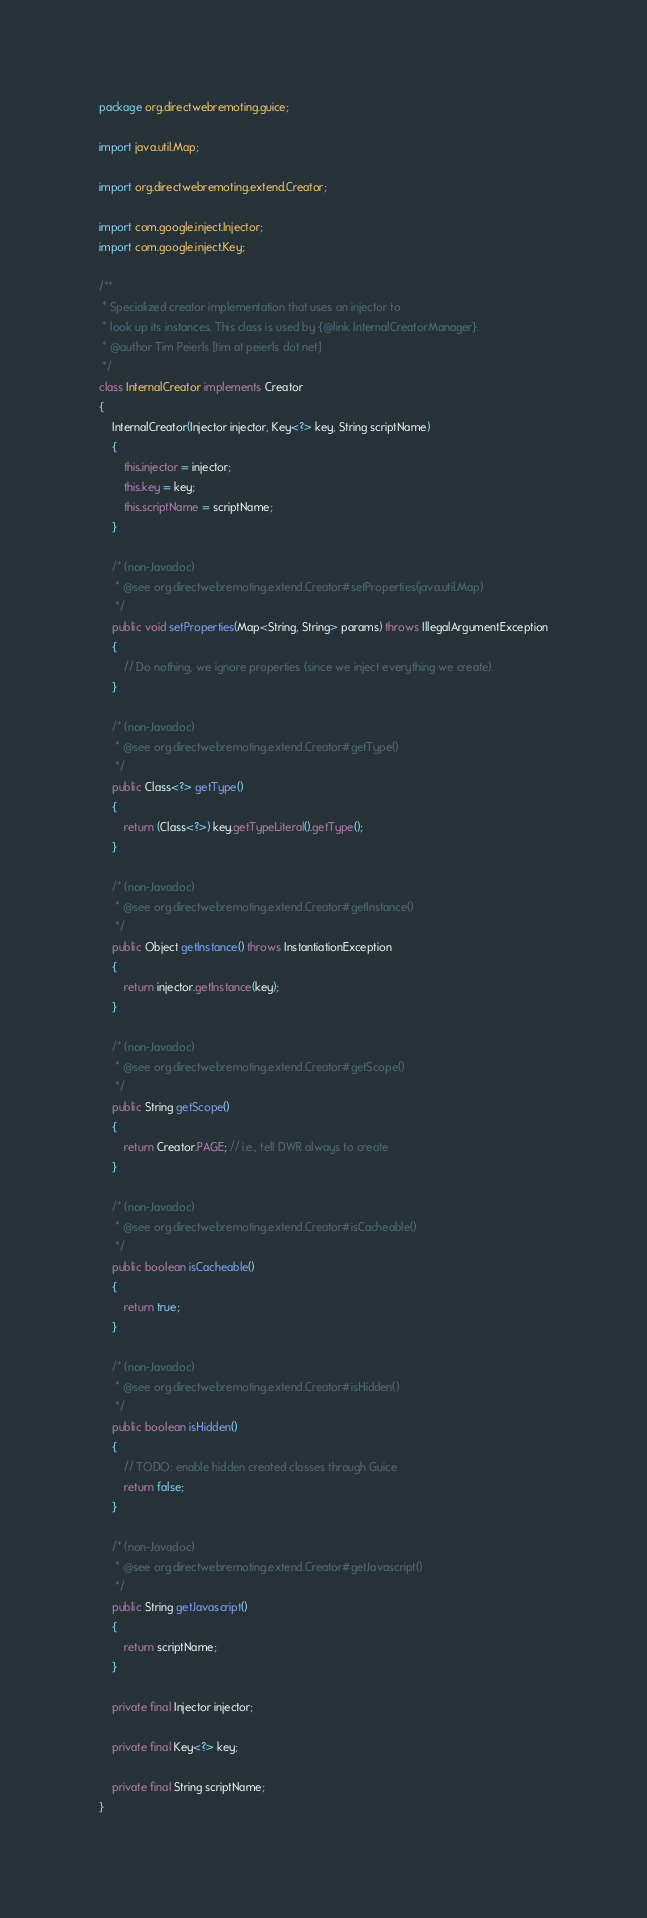Convert code to text. <code><loc_0><loc_0><loc_500><loc_500><_Java_>package org.directwebremoting.guice;

import java.util.Map;

import org.directwebremoting.extend.Creator;

import com.google.inject.Injector;
import com.google.inject.Key;

/**
 * Specialized creator implementation that uses an injector to
 * look up its instances. This class is used by {@link InternalCreatorManager}.
 * @author Tim Peierls [tim at peierls dot net]
 */
class InternalCreator implements Creator
{
    InternalCreator(Injector injector, Key<?> key, String scriptName)
    {
        this.injector = injector;
        this.key = key;
        this.scriptName = scriptName;
    }

    /* (non-Javadoc)
     * @see org.directwebremoting.extend.Creator#setProperties(java.util.Map)
     */
    public void setProperties(Map<String, String> params) throws IllegalArgumentException
    {
        // Do nothing, we ignore properties (since we inject everything we create).
    }

    /* (non-Javadoc)
     * @see org.directwebremoting.extend.Creator#getType()
     */
    public Class<?> getType()
    {
        return (Class<?>) key.getTypeLiteral().getType();
    }

    /* (non-Javadoc)
     * @see org.directwebremoting.extend.Creator#getInstance()
     */
    public Object getInstance() throws InstantiationException
    {
        return injector.getInstance(key);
    }

    /* (non-Javadoc)
     * @see org.directwebremoting.extend.Creator#getScope()
     */
    public String getScope()
    {
        return Creator.PAGE; // i.e., tell DWR always to create
    }

    /* (non-Javadoc)
     * @see org.directwebremoting.extend.Creator#isCacheable()
     */
    public boolean isCacheable()
    {
        return true;
    }

    /* (non-Javadoc)
     * @see org.directwebremoting.extend.Creator#isHidden()
     */
    public boolean isHidden()
    {
        // TODO: enable hidden created classes through Guice
        return false;
    }

    /* (non-Javadoc)
     * @see org.directwebremoting.extend.Creator#getJavascript()
     */
    public String getJavascript()
    {
        return scriptName;
    }

    private final Injector injector;

    private final Key<?> key;

    private final String scriptName;
}
</code> 